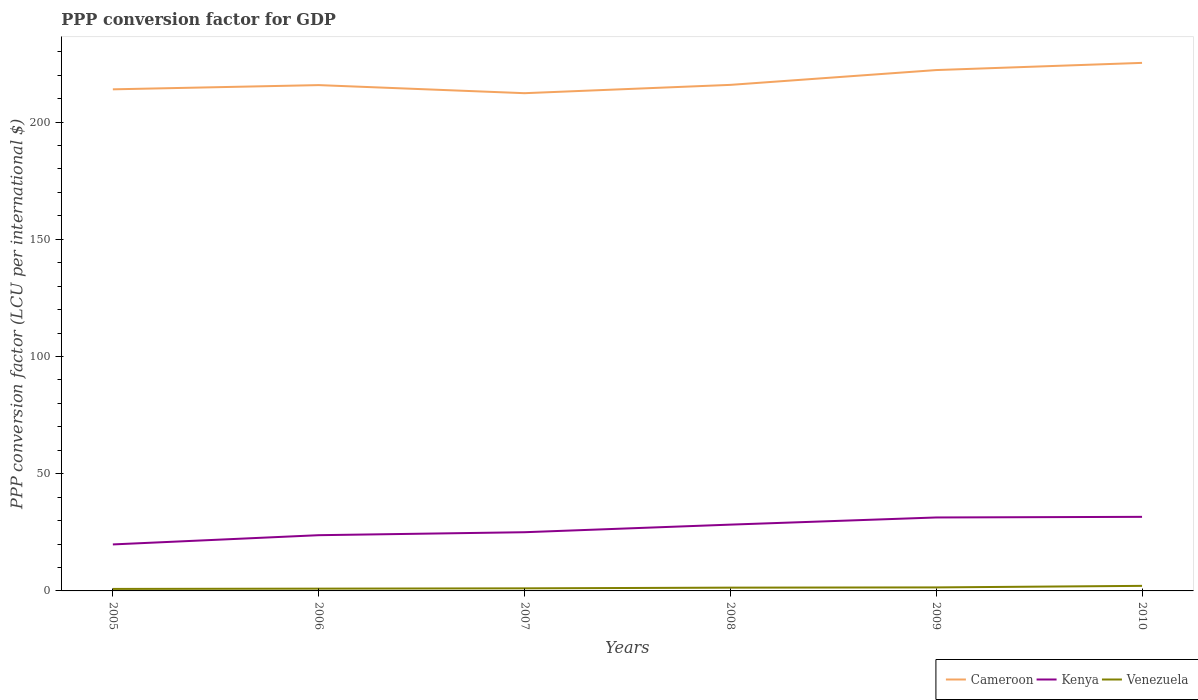Across all years, what is the maximum PPP conversion factor for GDP in Kenya?
Provide a succinct answer. 19.83. In which year was the PPP conversion factor for GDP in Venezuela maximum?
Ensure brevity in your answer.  2005. What is the total PPP conversion factor for GDP in Kenya in the graph?
Make the answer very short. -1.27. What is the difference between the highest and the second highest PPP conversion factor for GDP in Cameroon?
Provide a short and direct response. 12.93. Is the PPP conversion factor for GDP in Cameroon strictly greater than the PPP conversion factor for GDP in Kenya over the years?
Your response must be concise. No. How many lines are there?
Your answer should be compact. 3. What is the difference between two consecutive major ticks on the Y-axis?
Your response must be concise. 50. How many legend labels are there?
Your answer should be very brief. 3. How are the legend labels stacked?
Ensure brevity in your answer.  Horizontal. What is the title of the graph?
Your answer should be very brief. PPP conversion factor for GDP. Does "Philippines" appear as one of the legend labels in the graph?
Offer a terse response. No. What is the label or title of the Y-axis?
Provide a short and direct response. PPP conversion factor (LCU per international $). What is the PPP conversion factor (LCU per international $) of Cameroon in 2005?
Your answer should be very brief. 213.94. What is the PPP conversion factor (LCU per international $) in Kenya in 2005?
Your answer should be very brief. 19.83. What is the PPP conversion factor (LCU per international $) in Venezuela in 2005?
Offer a very short reply. 0.85. What is the PPP conversion factor (LCU per international $) of Cameroon in 2006?
Offer a terse response. 215.74. What is the PPP conversion factor (LCU per international $) in Kenya in 2006?
Give a very brief answer. 23.77. What is the PPP conversion factor (LCU per international $) of Venezuela in 2006?
Ensure brevity in your answer.  0.98. What is the PPP conversion factor (LCU per international $) of Cameroon in 2007?
Your response must be concise. 212.29. What is the PPP conversion factor (LCU per international $) in Kenya in 2007?
Make the answer very short. 25.04. What is the PPP conversion factor (LCU per international $) of Venezuela in 2007?
Your answer should be very brief. 1.1. What is the PPP conversion factor (LCU per international $) of Cameroon in 2008?
Ensure brevity in your answer.  215.84. What is the PPP conversion factor (LCU per international $) in Kenya in 2008?
Your response must be concise. 28.27. What is the PPP conversion factor (LCU per international $) in Venezuela in 2008?
Make the answer very short. 1.4. What is the PPP conversion factor (LCU per international $) in Cameroon in 2009?
Provide a short and direct response. 222.15. What is the PPP conversion factor (LCU per international $) of Kenya in 2009?
Provide a succinct answer. 31.33. What is the PPP conversion factor (LCU per international $) of Venezuela in 2009?
Your response must be concise. 1.5. What is the PPP conversion factor (LCU per international $) of Cameroon in 2010?
Your answer should be compact. 225.22. What is the PPP conversion factor (LCU per international $) of Kenya in 2010?
Provide a short and direct response. 31.6. What is the PPP conversion factor (LCU per international $) of Venezuela in 2010?
Make the answer very short. 2.16. Across all years, what is the maximum PPP conversion factor (LCU per international $) of Cameroon?
Your response must be concise. 225.22. Across all years, what is the maximum PPP conversion factor (LCU per international $) of Kenya?
Ensure brevity in your answer.  31.6. Across all years, what is the maximum PPP conversion factor (LCU per international $) in Venezuela?
Provide a succinct answer. 2.16. Across all years, what is the minimum PPP conversion factor (LCU per international $) in Cameroon?
Keep it short and to the point. 212.29. Across all years, what is the minimum PPP conversion factor (LCU per international $) of Kenya?
Provide a short and direct response. 19.83. Across all years, what is the minimum PPP conversion factor (LCU per international $) of Venezuela?
Offer a very short reply. 0.85. What is the total PPP conversion factor (LCU per international $) of Cameroon in the graph?
Give a very brief answer. 1305.18. What is the total PPP conversion factor (LCU per international $) in Kenya in the graph?
Your answer should be compact. 159.83. What is the total PPP conversion factor (LCU per international $) in Venezuela in the graph?
Provide a succinct answer. 7.99. What is the difference between the PPP conversion factor (LCU per international $) in Cameroon in 2005 and that in 2006?
Your answer should be compact. -1.8. What is the difference between the PPP conversion factor (LCU per international $) in Kenya in 2005 and that in 2006?
Your answer should be very brief. -3.94. What is the difference between the PPP conversion factor (LCU per international $) of Venezuela in 2005 and that in 2006?
Ensure brevity in your answer.  -0.12. What is the difference between the PPP conversion factor (LCU per international $) in Cameroon in 2005 and that in 2007?
Your answer should be compact. 1.64. What is the difference between the PPP conversion factor (LCU per international $) in Kenya in 2005 and that in 2007?
Offer a terse response. -5.2. What is the difference between the PPP conversion factor (LCU per international $) of Venezuela in 2005 and that in 2007?
Keep it short and to the point. -0.24. What is the difference between the PPP conversion factor (LCU per international $) of Cameroon in 2005 and that in 2008?
Your response must be concise. -1.9. What is the difference between the PPP conversion factor (LCU per international $) of Kenya in 2005 and that in 2008?
Your answer should be compact. -8.44. What is the difference between the PPP conversion factor (LCU per international $) in Venezuela in 2005 and that in 2008?
Your answer should be compact. -0.55. What is the difference between the PPP conversion factor (LCU per international $) of Cameroon in 2005 and that in 2009?
Give a very brief answer. -8.22. What is the difference between the PPP conversion factor (LCU per international $) in Kenya in 2005 and that in 2009?
Offer a very short reply. -11.49. What is the difference between the PPP conversion factor (LCU per international $) of Venezuela in 2005 and that in 2009?
Ensure brevity in your answer.  -0.65. What is the difference between the PPP conversion factor (LCU per international $) in Cameroon in 2005 and that in 2010?
Your response must be concise. -11.28. What is the difference between the PPP conversion factor (LCU per international $) in Kenya in 2005 and that in 2010?
Offer a very short reply. -11.76. What is the difference between the PPP conversion factor (LCU per international $) of Venezuela in 2005 and that in 2010?
Your response must be concise. -1.31. What is the difference between the PPP conversion factor (LCU per international $) of Cameroon in 2006 and that in 2007?
Provide a short and direct response. 3.44. What is the difference between the PPP conversion factor (LCU per international $) of Kenya in 2006 and that in 2007?
Your answer should be compact. -1.27. What is the difference between the PPP conversion factor (LCU per international $) in Venezuela in 2006 and that in 2007?
Provide a short and direct response. -0.12. What is the difference between the PPP conversion factor (LCU per international $) in Cameroon in 2006 and that in 2008?
Your answer should be very brief. -0.1. What is the difference between the PPP conversion factor (LCU per international $) in Kenya in 2006 and that in 2008?
Your response must be concise. -4.5. What is the difference between the PPP conversion factor (LCU per international $) in Venezuela in 2006 and that in 2008?
Keep it short and to the point. -0.42. What is the difference between the PPP conversion factor (LCU per international $) of Cameroon in 2006 and that in 2009?
Ensure brevity in your answer.  -6.42. What is the difference between the PPP conversion factor (LCU per international $) of Kenya in 2006 and that in 2009?
Make the answer very short. -7.56. What is the difference between the PPP conversion factor (LCU per international $) in Venezuela in 2006 and that in 2009?
Provide a short and direct response. -0.52. What is the difference between the PPP conversion factor (LCU per international $) in Cameroon in 2006 and that in 2010?
Your answer should be very brief. -9.48. What is the difference between the PPP conversion factor (LCU per international $) of Kenya in 2006 and that in 2010?
Offer a terse response. -7.83. What is the difference between the PPP conversion factor (LCU per international $) in Venezuela in 2006 and that in 2010?
Offer a very short reply. -1.19. What is the difference between the PPP conversion factor (LCU per international $) in Cameroon in 2007 and that in 2008?
Make the answer very short. -3.54. What is the difference between the PPP conversion factor (LCU per international $) in Kenya in 2007 and that in 2008?
Keep it short and to the point. -3.24. What is the difference between the PPP conversion factor (LCU per international $) of Venezuela in 2007 and that in 2008?
Your answer should be very brief. -0.3. What is the difference between the PPP conversion factor (LCU per international $) in Cameroon in 2007 and that in 2009?
Offer a terse response. -9.86. What is the difference between the PPP conversion factor (LCU per international $) in Kenya in 2007 and that in 2009?
Make the answer very short. -6.29. What is the difference between the PPP conversion factor (LCU per international $) of Venezuela in 2007 and that in 2009?
Provide a short and direct response. -0.4. What is the difference between the PPP conversion factor (LCU per international $) of Cameroon in 2007 and that in 2010?
Make the answer very short. -12.93. What is the difference between the PPP conversion factor (LCU per international $) of Kenya in 2007 and that in 2010?
Ensure brevity in your answer.  -6.56. What is the difference between the PPP conversion factor (LCU per international $) in Venezuela in 2007 and that in 2010?
Make the answer very short. -1.06. What is the difference between the PPP conversion factor (LCU per international $) in Cameroon in 2008 and that in 2009?
Keep it short and to the point. -6.31. What is the difference between the PPP conversion factor (LCU per international $) of Kenya in 2008 and that in 2009?
Make the answer very short. -3.05. What is the difference between the PPP conversion factor (LCU per international $) of Venezuela in 2008 and that in 2009?
Your response must be concise. -0.1. What is the difference between the PPP conversion factor (LCU per international $) of Cameroon in 2008 and that in 2010?
Give a very brief answer. -9.38. What is the difference between the PPP conversion factor (LCU per international $) in Kenya in 2008 and that in 2010?
Give a very brief answer. -3.32. What is the difference between the PPP conversion factor (LCU per international $) of Venezuela in 2008 and that in 2010?
Give a very brief answer. -0.76. What is the difference between the PPP conversion factor (LCU per international $) in Cameroon in 2009 and that in 2010?
Provide a short and direct response. -3.07. What is the difference between the PPP conversion factor (LCU per international $) of Kenya in 2009 and that in 2010?
Your response must be concise. -0.27. What is the difference between the PPP conversion factor (LCU per international $) of Venezuela in 2009 and that in 2010?
Offer a very short reply. -0.66. What is the difference between the PPP conversion factor (LCU per international $) of Cameroon in 2005 and the PPP conversion factor (LCU per international $) of Kenya in 2006?
Provide a short and direct response. 190.17. What is the difference between the PPP conversion factor (LCU per international $) of Cameroon in 2005 and the PPP conversion factor (LCU per international $) of Venezuela in 2006?
Your answer should be very brief. 212.96. What is the difference between the PPP conversion factor (LCU per international $) in Kenya in 2005 and the PPP conversion factor (LCU per international $) in Venezuela in 2006?
Provide a short and direct response. 18.86. What is the difference between the PPP conversion factor (LCU per international $) in Cameroon in 2005 and the PPP conversion factor (LCU per international $) in Kenya in 2007?
Ensure brevity in your answer.  188.9. What is the difference between the PPP conversion factor (LCU per international $) of Cameroon in 2005 and the PPP conversion factor (LCU per international $) of Venezuela in 2007?
Offer a very short reply. 212.84. What is the difference between the PPP conversion factor (LCU per international $) in Kenya in 2005 and the PPP conversion factor (LCU per international $) in Venezuela in 2007?
Offer a very short reply. 18.74. What is the difference between the PPP conversion factor (LCU per international $) of Cameroon in 2005 and the PPP conversion factor (LCU per international $) of Kenya in 2008?
Make the answer very short. 185.66. What is the difference between the PPP conversion factor (LCU per international $) in Cameroon in 2005 and the PPP conversion factor (LCU per international $) in Venezuela in 2008?
Ensure brevity in your answer.  212.54. What is the difference between the PPP conversion factor (LCU per international $) of Kenya in 2005 and the PPP conversion factor (LCU per international $) of Venezuela in 2008?
Your answer should be very brief. 18.43. What is the difference between the PPP conversion factor (LCU per international $) of Cameroon in 2005 and the PPP conversion factor (LCU per international $) of Kenya in 2009?
Offer a terse response. 182.61. What is the difference between the PPP conversion factor (LCU per international $) in Cameroon in 2005 and the PPP conversion factor (LCU per international $) in Venezuela in 2009?
Give a very brief answer. 212.44. What is the difference between the PPP conversion factor (LCU per international $) in Kenya in 2005 and the PPP conversion factor (LCU per international $) in Venezuela in 2009?
Keep it short and to the point. 18.33. What is the difference between the PPP conversion factor (LCU per international $) of Cameroon in 2005 and the PPP conversion factor (LCU per international $) of Kenya in 2010?
Make the answer very short. 182.34. What is the difference between the PPP conversion factor (LCU per international $) in Cameroon in 2005 and the PPP conversion factor (LCU per international $) in Venezuela in 2010?
Offer a very short reply. 211.77. What is the difference between the PPP conversion factor (LCU per international $) in Kenya in 2005 and the PPP conversion factor (LCU per international $) in Venezuela in 2010?
Make the answer very short. 17.67. What is the difference between the PPP conversion factor (LCU per international $) of Cameroon in 2006 and the PPP conversion factor (LCU per international $) of Kenya in 2007?
Your response must be concise. 190.7. What is the difference between the PPP conversion factor (LCU per international $) in Cameroon in 2006 and the PPP conversion factor (LCU per international $) in Venezuela in 2007?
Offer a very short reply. 214.64. What is the difference between the PPP conversion factor (LCU per international $) of Kenya in 2006 and the PPP conversion factor (LCU per international $) of Venezuela in 2007?
Keep it short and to the point. 22.67. What is the difference between the PPP conversion factor (LCU per international $) in Cameroon in 2006 and the PPP conversion factor (LCU per international $) in Kenya in 2008?
Offer a very short reply. 187.46. What is the difference between the PPP conversion factor (LCU per international $) of Cameroon in 2006 and the PPP conversion factor (LCU per international $) of Venezuela in 2008?
Ensure brevity in your answer.  214.34. What is the difference between the PPP conversion factor (LCU per international $) in Kenya in 2006 and the PPP conversion factor (LCU per international $) in Venezuela in 2008?
Provide a short and direct response. 22.37. What is the difference between the PPP conversion factor (LCU per international $) of Cameroon in 2006 and the PPP conversion factor (LCU per international $) of Kenya in 2009?
Your response must be concise. 184.41. What is the difference between the PPP conversion factor (LCU per international $) in Cameroon in 2006 and the PPP conversion factor (LCU per international $) in Venezuela in 2009?
Offer a very short reply. 214.24. What is the difference between the PPP conversion factor (LCU per international $) in Kenya in 2006 and the PPP conversion factor (LCU per international $) in Venezuela in 2009?
Provide a succinct answer. 22.27. What is the difference between the PPP conversion factor (LCU per international $) in Cameroon in 2006 and the PPP conversion factor (LCU per international $) in Kenya in 2010?
Ensure brevity in your answer.  184.14. What is the difference between the PPP conversion factor (LCU per international $) in Cameroon in 2006 and the PPP conversion factor (LCU per international $) in Venezuela in 2010?
Make the answer very short. 213.58. What is the difference between the PPP conversion factor (LCU per international $) in Kenya in 2006 and the PPP conversion factor (LCU per international $) in Venezuela in 2010?
Your response must be concise. 21.61. What is the difference between the PPP conversion factor (LCU per international $) in Cameroon in 2007 and the PPP conversion factor (LCU per international $) in Kenya in 2008?
Ensure brevity in your answer.  184.02. What is the difference between the PPP conversion factor (LCU per international $) in Cameroon in 2007 and the PPP conversion factor (LCU per international $) in Venezuela in 2008?
Give a very brief answer. 210.89. What is the difference between the PPP conversion factor (LCU per international $) in Kenya in 2007 and the PPP conversion factor (LCU per international $) in Venezuela in 2008?
Offer a terse response. 23.64. What is the difference between the PPP conversion factor (LCU per international $) of Cameroon in 2007 and the PPP conversion factor (LCU per international $) of Kenya in 2009?
Your response must be concise. 180.97. What is the difference between the PPP conversion factor (LCU per international $) of Cameroon in 2007 and the PPP conversion factor (LCU per international $) of Venezuela in 2009?
Provide a short and direct response. 210.79. What is the difference between the PPP conversion factor (LCU per international $) of Kenya in 2007 and the PPP conversion factor (LCU per international $) of Venezuela in 2009?
Your response must be concise. 23.54. What is the difference between the PPP conversion factor (LCU per international $) in Cameroon in 2007 and the PPP conversion factor (LCU per international $) in Kenya in 2010?
Your response must be concise. 180.7. What is the difference between the PPP conversion factor (LCU per international $) of Cameroon in 2007 and the PPP conversion factor (LCU per international $) of Venezuela in 2010?
Give a very brief answer. 210.13. What is the difference between the PPP conversion factor (LCU per international $) of Kenya in 2007 and the PPP conversion factor (LCU per international $) of Venezuela in 2010?
Keep it short and to the point. 22.87. What is the difference between the PPP conversion factor (LCU per international $) in Cameroon in 2008 and the PPP conversion factor (LCU per international $) in Kenya in 2009?
Provide a short and direct response. 184.51. What is the difference between the PPP conversion factor (LCU per international $) of Cameroon in 2008 and the PPP conversion factor (LCU per international $) of Venezuela in 2009?
Ensure brevity in your answer.  214.34. What is the difference between the PPP conversion factor (LCU per international $) in Kenya in 2008 and the PPP conversion factor (LCU per international $) in Venezuela in 2009?
Provide a short and direct response. 26.78. What is the difference between the PPP conversion factor (LCU per international $) in Cameroon in 2008 and the PPP conversion factor (LCU per international $) in Kenya in 2010?
Keep it short and to the point. 184.24. What is the difference between the PPP conversion factor (LCU per international $) in Cameroon in 2008 and the PPP conversion factor (LCU per international $) in Venezuela in 2010?
Ensure brevity in your answer.  213.68. What is the difference between the PPP conversion factor (LCU per international $) in Kenya in 2008 and the PPP conversion factor (LCU per international $) in Venezuela in 2010?
Your answer should be very brief. 26.11. What is the difference between the PPP conversion factor (LCU per international $) of Cameroon in 2009 and the PPP conversion factor (LCU per international $) of Kenya in 2010?
Your answer should be compact. 190.56. What is the difference between the PPP conversion factor (LCU per international $) of Cameroon in 2009 and the PPP conversion factor (LCU per international $) of Venezuela in 2010?
Your response must be concise. 219.99. What is the difference between the PPP conversion factor (LCU per international $) in Kenya in 2009 and the PPP conversion factor (LCU per international $) in Venezuela in 2010?
Your answer should be compact. 29.17. What is the average PPP conversion factor (LCU per international $) of Cameroon per year?
Provide a short and direct response. 217.53. What is the average PPP conversion factor (LCU per international $) of Kenya per year?
Ensure brevity in your answer.  26.64. What is the average PPP conversion factor (LCU per international $) in Venezuela per year?
Keep it short and to the point. 1.33. In the year 2005, what is the difference between the PPP conversion factor (LCU per international $) of Cameroon and PPP conversion factor (LCU per international $) of Kenya?
Give a very brief answer. 194.1. In the year 2005, what is the difference between the PPP conversion factor (LCU per international $) in Cameroon and PPP conversion factor (LCU per international $) in Venezuela?
Provide a succinct answer. 213.08. In the year 2005, what is the difference between the PPP conversion factor (LCU per international $) of Kenya and PPP conversion factor (LCU per international $) of Venezuela?
Offer a terse response. 18.98. In the year 2006, what is the difference between the PPP conversion factor (LCU per international $) of Cameroon and PPP conversion factor (LCU per international $) of Kenya?
Keep it short and to the point. 191.97. In the year 2006, what is the difference between the PPP conversion factor (LCU per international $) of Cameroon and PPP conversion factor (LCU per international $) of Venezuela?
Provide a short and direct response. 214.76. In the year 2006, what is the difference between the PPP conversion factor (LCU per international $) in Kenya and PPP conversion factor (LCU per international $) in Venezuela?
Your response must be concise. 22.79. In the year 2007, what is the difference between the PPP conversion factor (LCU per international $) in Cameroon and PPP conversion factor (LCU per international $) in Kenya?
Give a very brief answer. 187.26. In the year 2007, what is the difference between the PPP conversion factor (LCU per international $) of Cameroon and PPP conversion factor (LCU per international $) of Venezuela?
Your response must be concise. 211.2. In the year 2007, what is the difference between the PPP conversion factor (LCU per international $) of Kenya and PPP conversion factor (LCU per international $) of Venezuela?
Give a very brief answer. 23.94. In the year 2008, what is the difference between the PPP conversion factor (LCU per international $) in Cameroon and PPP conversion factor (LCU per international $) in Kenya?
Give a very brief answer. 187.56. In the year 2008, what is the difference between the PPP conversion factor (LCU per international $) in Cameroon and PPP conversion factor (LCU per international $) in Venezuela?
Provide a succinct answer. 214.44. In the year 2008, what is the difference between the PPP conversion factor (LCU per international $) of Kenya and PPP conversion factor (LCU per international $) of Venezuela?
Give a very brief answer. 26.87. In the year 2009, what is the difference between the PPP conversion factor (LCU per international $) in Cameroon and PPP conversion factor (LCU per international $) in Kenya?
Offer a very short reply. 190.83. In the year 2009, what is the difference between the PPP conversion factor (LCU per international $) of Cameroon and PPP conversion factor (LCU per international $) of Venezuela?
Offer a terse response. 220.65. In the year 2009, what is the difference between the PPP conversion factor (LCU per international $) of Kenya and PPP conversion factor (LCU per international $) of Venezuela?
Your answer should be compact. 29.83. In the year 2010, what is the difference between the PPP conversion factor (LCU per international $) in Cameroon and PPP conversion factor (LCU per international $) in Kenya?
Ensure brevity in your answer.  193.62. In the year 2010, what is the difference between the PPP conversion factor (LCU per international $) of Cameroon and PPP conversion factor (LCU per international $) of Venezuela?
Make the answer very short. 223.06. In the year 2010, what is the difference between the PPP conversion factor (LCU per international $) of Kenya and PPP conversion factor (LCU per international $) of Venezuela?
Make the answer very short. 29.44. What is the ratio of the PPP conversion factor (LCU per international $) of Kenya in 2005 to that in 2006?
Your response must be concise. 0.83. What is the ratio of the PPP conversion factor (LCU per international $) of Venezuela in 2005 to that in 2006?
Make the answer very short. 0.87. What is the ratio of the PPP conversion factor (LCU per international $) of Cameroon in 2005 to that in 2007?
Your answer should be compact. 1.01. What is the ratio of the PPP conversion factor (LCU per international $) in Kenya in 2005 to that in 2007?
Keep it short and to the point. 0.79. What is the ratio of the PPP conversion factor (LCU per international $) in Venezuela in 2005 to that in 2007?
Your answer should be compact. 0.78. What is the ratio of the PPP conversion factor (LCU per international $) in Kenya in 2005 to that in 2008?
Offer a terse response. 0.7. What is the ratio of the PPP conversion factor (LCU per international $) of Venezuela in 2005 to that in 2008?
Give a very brief answer. 0.61. What is the ratio of the PPP conversion factor (LCU per international $) in Cameroon in 2005 to that in 2009?
Give a very brief answer. 0.96. What is the ratio of the PPP conversion factor (LCU per international $) in Kenya in 2005 to that in 2009?
Offer a very short reply. 0.63. What is the ratio of the PPP conversion factor (LCU per international $) in Venezuela in 2005 to that in 2009?
Keep it short and to the point. 0.57. What is the ratio of the PPP conversion factor (LCU per international $) in Cameroon in 2005 to that in 2010?
Your response must be concise. 0.95. What is the ratio of the PPP conversion factor (LCU per international $) in Kenya in 2005 to that in 2010?
Provide a short and direct response. 0.63. What is the ratio of the PPP conversion factor (LCU per international $) in Venezuela in 2005 to that in 2010?
Your answer should be very brief. 0.39. What is the ratio of the PPP conversion factor (LCU per international $) of Cameroon in 2006 to that in 2007?
Your answer should be compact. 1.02. What is the ratio of the PPP conversion factor (LCU per international $) of Kenya in 2006 to that in 2007?
Give a very brief answer. 0.95. What is the ratio of the PPP conversion factor (LCU per international $) in Venezuela in 2006 to that in 2007?
Your response must be concise. 0.89. What is the ratio of the PPP conversion factor (LCU per international $) in Cameroon in 2006 to that in 2008?
Your response must be concise. 1. What is the ratio of the PPP conversion factor (LCU per international $) of Kenya in 2006 to that in 2008?
Your response must be concise. 0.84. What is the ratio of the PPP conversion factor (LCU per international $) in Venezuela in 2006 to that in 2008?
Give a very brief answer. 0.7. What is the ratio of the PPP conversion factor (LCU per international $) in Cameroon in 2006 to that in 2009?
Provide a succinct answer. 0.97. What is the ratio of the PPP conversion factor (LCU per international $) in Kenya in 2006 to that in 2009?
Ensure brevity in your answer.  0.76. What is the ratio of the PPP conversion factor (LCU per international $) of Venezuela in 2006 to that in 2009?
Offer a very short reply. 0.65. What is the ratio of the PPP conversion factor (LCU per international $) of Cameroon in 2006 to that in 2010?
Give a very brief answer. 0.96. What is the ratio of the PPP conversion factor (LCU per international $) of Kenya in 2006 to that in 2010?
Your response must be concise. 0.75. What is the ratio of the PPP conversion factor (LCU per international $) of Venezuela in 2006 to that in 2010?
Provide a succinct answer. 0.45. What is the ratio of the PPP conversion factor (LCU per international $) in Cameroon in 2007 to that in 2008?
Ensure brevity in your answer.  0.98. What is the ratio of the PPP conversion factor (LCU per international $) in Kenya in 2007 to that in 2008?
Offer a terse response. 0.89. What is the ratio of the PPP conversion factor (LCU per international $) of Venezuela in 2007 to that in 2008?
Your response must be concise. 0.78. What is the ratio of the PPP conversion factor (LCU per international $) of Cameroon in 2007 to that in 2009?
Give a very brief answer. 0.96. What is the ratio of the PPP conversion factor (LCU per international $) in Kenya in 2007 to that in 2009?
Keep it short and to the point. 0.8. What is the ratio of the PPP conversion factor (LCU per international $) in Venezuela in 2007 to that in 2009?
Give a very brief answer. 0.73. What is the ratio of the PPP conversion factor (LCU per international $) in Cameroon in 2007 to that in 2010?
Offer a very short reply. 0.94. What is the ratio of the PPP conversion factor (LCU per international $) of Kenya in 2007 to that in 2010?
Provide a succinct answer. 0.79. What is the ratio of the PPP conversion factor (LCU per international $) of Venezuela in 2007 to that in 2010?
Give a very brief answer. 0.51. What is the ratio of the PPP conversion factor (LCU per international $) of Cameroon in 2008 to that in 2009?
Offer a very short reply. 0.97. What is the ratio of the PPP conversion factor (LCU per international $) in Kenya in 2008 to that in 2009?
Your answer should be very brief. 0.9. What is the ratio of the PPP conversion factor (LCU per international $) in Venezuela in 2008 to that in 2009?
Offer a very short reply. 0.93. What is the ratio of the PPP conversion factor (LCU per international $) of Cameroon in 2008 to that in 2010?
Your answer should be compact. 0.96. What is the ratio of the PPP conversion factor (LCU per international $) in Kenya in 2008 to that in 2010?
Keep it short and to the point. 0.89. What is the ratio of the PPP conversion factor (LCU per international $) in Venezuela in 2008 to that in 2010?
Offer a terse response. 0.65. What is the ratio of the PPP conversion factor (LCU per international $) in Cameroon in 2009 to that in 2010?
Provide a succinct answer. 0.99. What is the ratio of the PPP conversion factor (LCU per international $) of Kenya in 2009 to that in 2010?
Offer a terse response. 0.99. What is the ratio of the PPP conversion factor (LCU per international $) in Venezuela in 2009 to that in 2010?
Your answer should be very brief. 0.69. What is the difference between the highest and the second highest PPP conversion factor (LCU per international $) in Cameroon?
Provide a short and direct response. 3.07. What is the difference between the highest and the second highest PPP conversion factor (LCU per international $) in Kenya?
Your answer should be very brief. 0.27. What is the difference between the highest and the second highest PPP conversion factor (LCU per international $) of Venezuela?
Give a very brief answer. 0.66. What is the difference between the highest and the lowest PPP conversion factor (LCU per international $) of Cameroon?
Keep it short and to the point. 12.93. What is the difference between the highest and the lowest PPP conversion factor (LCU per international $) of Kenya?
Offer a very short reply. 11.76. What is the difference between the highest and the lowest PPP conversion factor (LCU per international $) of Venezuela?
Your answer should be very brief. 1.31. 